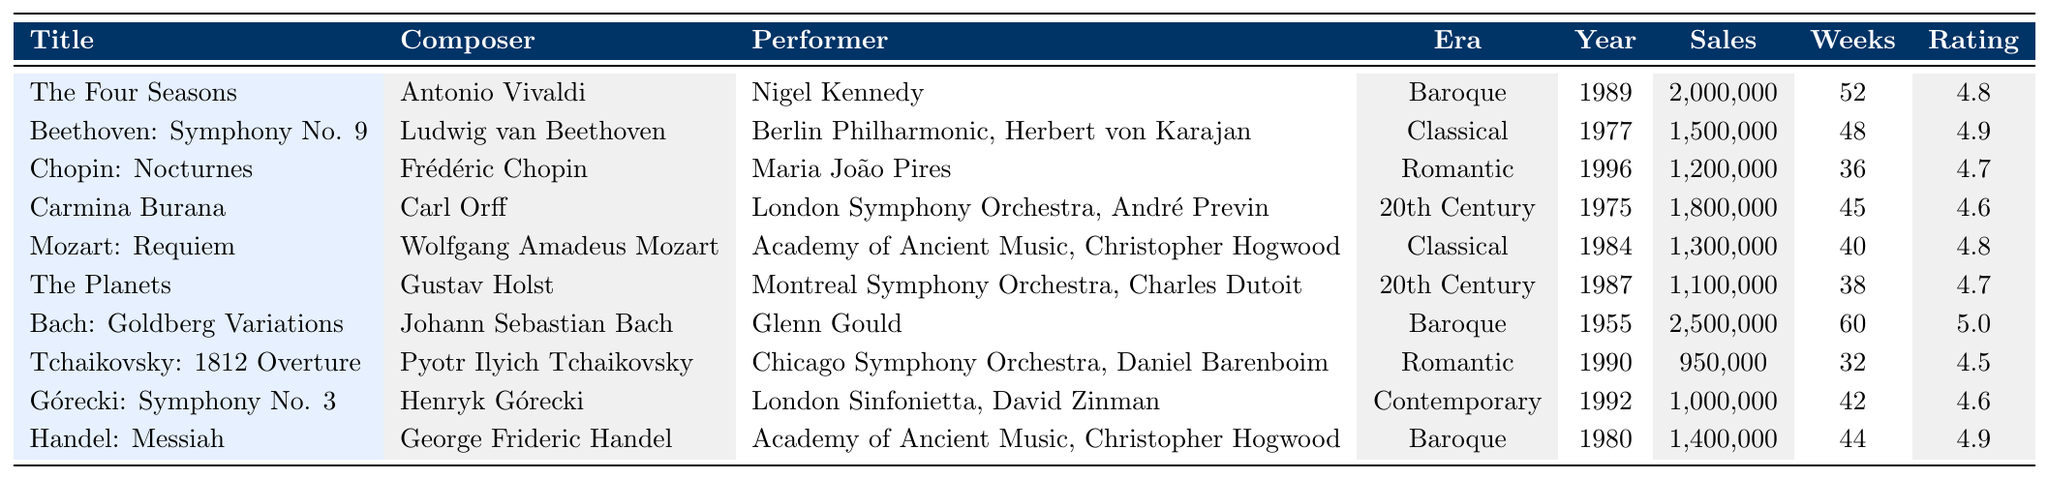What is the best-selling album on this list? The album "Bach: Goldberg Variations" has the highest sales figure of 2,500,000.
Answer: Bach: Goldberg Variations Who performed "The Four Seasons"? According to the table, "The Four Seasons" was performed by Nigel Kennedy.
Answer: Nigel Kennedy How many weeks did "Mozart: Requiem" stay on the chart? "Mozart: Requiem" stayed on the chart for 40 weeks, as indicated in the table.
Answer: 40 weeks Which composer has an album rated 5.0? The album "Bach: Goldberg Variations" by Johann Sebastian Bach has a rating of 5.0.
Answer: Johann Sebastian Bach Which era has the highest total sales? To find this, we need to calculate the total sales for each era: Baroque (2,000,000 + 2,500,000 + 1,400,000 = 5,900,000), Classical (1,500,000 + 1,300,000 = 2,800,000), Romantic (1,200,000 + 950,000 = 2,150,000), 20th Century (1,800,000 + 1,100,000 = 2,900,000), Contemporary (1,000,000). Baroque has the highest total sales at 5,900,000.
Answer: Baroque Does "The Planets" have more sales than "Tchaikovsky: 1812 Overture"? "The Planets" has 1,100,000 in sales, while "Tchaikovsky: 1812 Overture" has 950,000. Therefore, it is true that "The Planets" has more sales.
Answer: Yes What is the average sales of the albums from the Romantic era? The total sales for the Romantic era are 1,200,000 + 950,000 = 2,150,000. There are 2 albums, so the average sales is 2,150,000 / 2 = 1,075,000.
Answer: 1,075,000 Which album was released in 1989? "The Four Seasons" was released in 1989, as listed in the year column.
Answer: The Four Seasons Is there any album from the Contemporary era that has a rating of 4.7 or above? The only album from the Contemporary era is "Górecki: Symphony No. 3," which has a rating of 4.6. Therefore, there are no albums with a rating of 4.7 or above in this era.
Answer: No Which performer collaborated with both Handel and Mozart? The performer Christopher Hogwood collaborated with both Handel for "Messiah" and Mozart for "Requiem."
Answer: Christopher Hogwood What is the difference in sales between the best and lowest-selling album? The best-selling album is "Bach: Goldberg Variations" with sales of 2,500,000 and the lowest-selling album is "Tchaikovsky: 1812 Overture" with 950,000. The difference is 2,500,000 - 950,000 = 1,550,000.
Answer: 1,550,000 